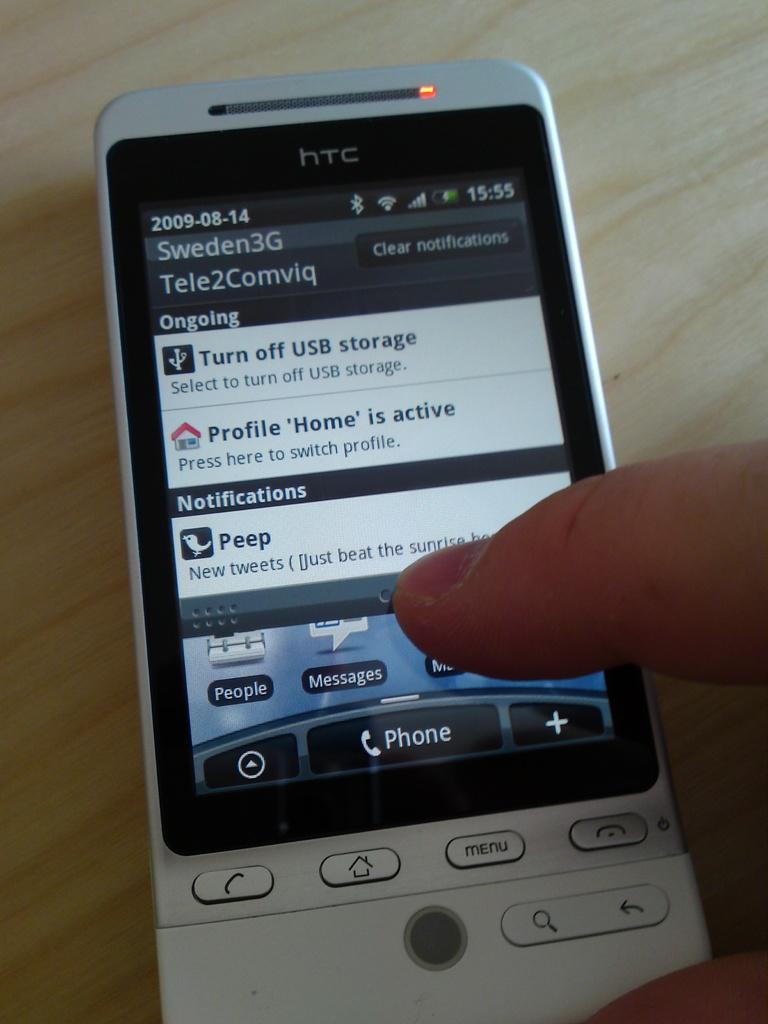<image>
Provide a brief description of the given image. An HTC phone shows the option to turn off USB storage. 